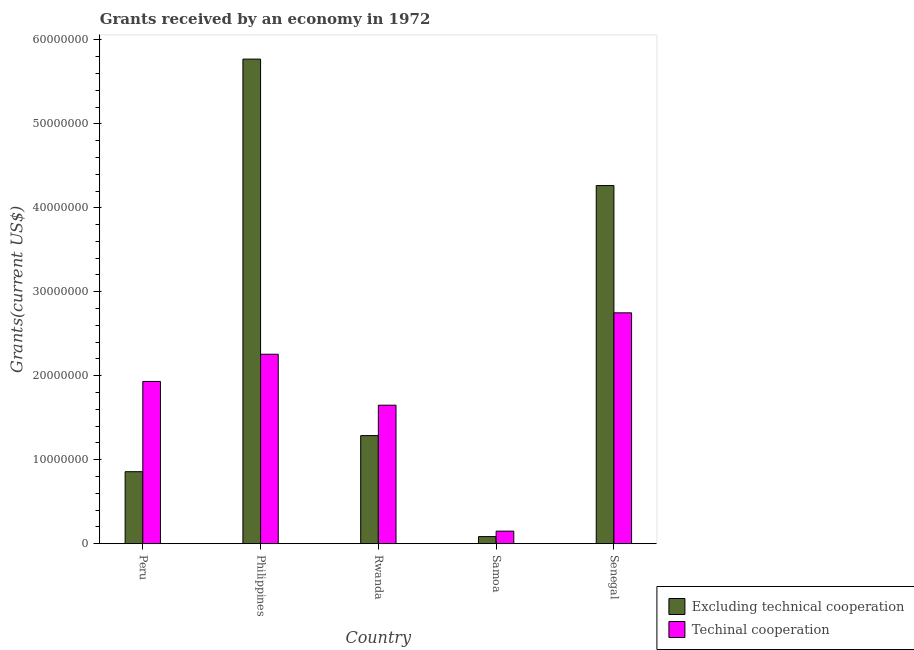How many different coloured bars are there?
Your answer should be compact. 2. How many groups of bars are there?
Give a very brief answer. 5. Are the number of bars per tick equal to the number of legend labels?
Make the answer very short. Yes. Are the number of bars on each tick of the X-axis equal?
Keep it short and to the point. Yes. What is the label of the 4th group of bars from the left?
Your answer should be compact. Samoa. In how many cases, is the number of bars for a given country not equal to the number of legend labels?
Ensure brevity in your answer.  0. What is the amount of grants received(including technical cooperation) in Peru?
Make the answer very short. 1.93e+07. Across all countries, what is the maximum amount of grants received(including technical cooperation)?
Ensure brevity in your answer.  2.75e+07. Across all countries, what is the minimum amount of grants received(including technical cooperation)?
Your answer should be very brief. 1.49e+06. In which country was the amount of grants received(including technical cooperation) maximum?
Your answer should be compact. Senegal. In which country was the amount of grants received(including technical cooperation) minimum?
Make the answer very short. Samoa. What is the total amount of grants received(excluding technical cooperation) in the graph?
Your response must be concise. 1.23e+08. What is the difference between the amount of grants received(including technical cooperation) in Peru and that in Philippines?
Your answer should be compact. -3.24e+06. What is the difference between the amount of grants received(including technical cooperation) in Samoa and the amount of grants received(excluding technical cooperation) in Philippines?
Your response must be concise. -5.62e+07. What is the average amount of grants received(including technical cooperation) per country?
Make the answer very short. 1.75e+07. What is the difference between the amount of grants received(including technical cooperation) and amount of grants received(excluding technical cooperation) in Samoa?
Your answer should be compact. 6.50e+05. In how many countries, is the amount of grants received(including technical cooperation) greater than 4000000 US$?
Ensure brevity in your answer.  4. What is the ratio of the amount of grants received(excluding technical cooperation) in Peru to that in Philippines?
Provide a short and direct response. 0.15. What is the difference between the highest and the second highest amount of grants received(including technical cooperation)?
Your answer should be compact. 4.93e+06. What is the difference between the highest and the lowest amount of grants received(excluding technical cooperation)?
Provide a succinct answer. 5.69e+07. In how many countries, is the amount of grants received(including technical cooperation) greater than the average amount of grants received(including technical cooperation) taken over all countries?
Your answer should be very brief. 3. Is the sum of the amount of grants received(excluding technical cooperation) in Peru and Philippines greater than the maximum amount of grants received(including technical cooperation) across all countries?
Ensure brevity in your answer.  Yes. What does the 2nd bar from the left in Samoa represents?
Offer a terse response. Techinal cooperation. What does the 2nd bar from the right in Peru represents?
Keep it short and to the point. Excluding technical cooperation. How many bars are there?
Give a very brief answer. 10. How many countries are there in the graph?
Offer a very short reply. 5. Are the values on the major ticks of Y-axis written in scientific E-notation?
Make the answer very short. No. Does the graph contain grids?
Your answer should be very brief. No. What is the title of the graph?
Your response must be concise. Grants received by an economy in 1972. What is the label or title of the X-axis?
Give a very brief answer. Country. What is the label or title of the Y-axis?
Give a very brief answer. Grants(current US$). What is the Grants(current US$) in Excluding technical cooperation in Peru?
Make the answer very short. 8.57e+06. What is the Grants(current US$) of Techinal cooperation in Peru?
Offer a very short reply. 1.93e+07. What is the Grants(current US$) of Excluding technical cooperation in Philippines?
Provide a succinct answer. 5.77e+07. What is the Grants(current US$) in Techinal cooperation in Philippines?
Ensure brevity in your answer.  2.26e+07. What is the Grants(current US$) of Excluding technical cooperation in Rwanda?
Keep it short and to the point. 1.29e+07. What is the Grants(current US$) of Techinal cooperation in Rwanda?
Ensure brevity in your answer.  1.65e+07. What is the Grants(current US$) in Excluding technical cooperation in Samoa?
Your response must be concise. 8.40e+05. What is the Grants(current US$) of Techinal cooperation in Samoa?
Offer a very short reply. 1.49e+06. What is the Grants(current US$) in Excluding technical cooperation in Senegal?
Keep it short and to the point. 4.26e+07. What is the Grants(current US$) in Techinal cooperation in Senegal?
Make the answer very short. 2.75e+07. Across all countries, what is the maximum Grants(current US$) of Excluding technical cooperation?
Give a very brief answer. 5.77e+07. Across all countries, what is the maximum Grants(current US$) in Techinal cooperation?
Provide a short and direct response. 2.75e+07. Across all countries, what is the minimum Grants(current US$) of Excluding technical cooperation?
Ensure brevity in your answer.  8.40e+05. Across all countries, what is the minimum Grants(current US$) in Techinal cooperation?
Provide a short and direct response. 1.49e+06. What is the total Grants(current US$) of Excluding technical cooperation in the graph?
Your response must be concise. 1.23e+08. What is the total Grants(current US$) of Techinal cooperation in the graph?
Offer a terse response. 8.74e+07. What is the difference between the Grants(current US$) in Excluding technical cooperation in Peru and that in Philippines?
Give a very brief answer. -4.91e+07. What is the difference between the Grants(current US$) of Techinal cooperation in Peru and that in Philippines?
Make the answer very short. -3.24e+06. What is the difference between the Grants(current US$) of Excluding technical cooperation in Peru and that in Rwanda?
Make the answer very short. -4.30e+06. What is the difference between the Grants(current US$) in Techinal cooperation in Peru and that in Rwanda?
Offer a very short reply. 2.83e+06. What is the difference between the Grants(current US$) of Excluding technical cooperation in Peru and that in Samoa?
Make the answer very short. 7.73e+06. What is the difference between the Grants(current US$) of Techinal cooperation in Peru and that in Samoa?
Offer a very short reply. 1.78e+07. What is the difference between the Grants(current US$) of Excluding technical cooperation in Peru and that in Senegal?
Give a very brief answer. -3.41e+07. What is the difference between the Grants(current US$) in Techinal cooperation in Peru and that in Senegal?
Provide a short and direct response. -8.17e+06. What is the difference between the Grants(current US$) in Excluding technical cooperation in Philippines and that in Rwanda?
Provide a short and direct response. 4.48e+07. What is the difference between the Grants(current US$) of Techinal cooperation in Philippines and that in Rwanda?
Make the answer very short. 6.07e+06. What is the difference between the Grants(current US$) of Excluding technical cooperation in Philippines and that in Samoa?
Your answer should be compact. 5.69e+07. What is the difference between the Grants(current US$) of Techinal cooperation in Philippines and that in Samoa?
Keep it short and to the point. 2.11e+07. What is the difference between the Grants(current US$) of Excluding technical cooperation in Philippines and that in Senegal?
Offer a terse response. 1.51e+07. What is the difference between the Grants(current US$) in Techinal cooperation in Philippines and that in Senegal?
Provide a short and direct response. -4.93e+06. What is the difference between the Grants(current US$) of Excluding technical cooperation in Rwanda and that in Samoa?
Ensure brevity in your answer.  1.20e+07. What is the difference between the Grants(current US$) of Techinal cooperation in Rwanda and that in Samoa?
Keep it short and to the point. 1.50e+07. What is the difference between the Grants(current US$) of Excluding technical cooperation in Rwanda and that in Senegal?
Your response must be concise. -2.98e+07. What is the difference between the Grants(current US$) of Techinal cooperation in Rwanda and that in Senegal?
Provide a succinct answer. -1.10e+07. What is the difference between the Grants(current US$) in Excluding technical cooperation in Samoa and that in Senegal?
Provide a short and direct response. -4.18e+07. What is the difference between the Grants(current US$) in Techinal cooperation in Samoa and that in Senegal?
Your answer should be very brief. -2.60e+07. What is the difference between the Grants(current US$) of Excluding technical cooperation in Peru and the Grants(current US$) of Techinal cooperation in Philippines?
Your response must be concise. -1.40e+07. What is the difference between the Grants(current US$) of Excluding technical cooperation in Peru and the Grants(current US$) of Techinal cooperation in Rwanda?
Give a very brief answer. -7.92e+06. What is the difference between the Grants(current US$) in Excluding technical cooperation in Peru and the Grants(current US$) in Techinal cooperation in Samoa?
Your answer should be compact. 7.08e+06. What is the difference between the Grants(current US$) in Excluding technical cooperation in Peru and the Grants(current US$) in Techinal cooperation in Senegal?
Offer a very short reply. -1.89e+07. What is the difference between the Grants(current US$) of Excluding technical cooperation in Philippines and the Grants(current US$) of Techinal cooperation in Rwanda?
Provide a succinct answer. 4.12e+07. What is the difference between the Grants(current US$) in Excluding technical cooperation in Philippines and the Grants(current US$) in Techinal cooperation in Samoa?
Your answer should be compact. 5.62e+07. What is the difference between the Grants(current US$) of Excluding technical cooperation in Philippines and the Grants(current US$) of Techinal cooperation in Senegal?
Your answer should be very brief. 3.02e+07. What is the difference between the Grants(current US$) of Excluding technical cooperation in Rwanda and the Grants(current US$) of Techinal cooperation in Samoa?
Offer a very short reply. 1.14e+07. What is the difference between the Grants(current US$) of Excluding technical cooperation in Rwanda and the Grants(current US$) of Techinal cooperation in Senegal?
Your response must be concise. -1.46e+07. What is the difference between the Grants(current US$) of Excluding technical cooperation in Samoa and the Grants(current US$) of Techinal cooperation in Senegal?
Your answer should be compact. -2.66e+07. What is the average Grants(current US$) in Excluding technical cooperation per country?
Your response must be concise. 2.45e+07. What is the average Grants(current US$) of Techinal cooperation per country?
Your answer should be very brief. 1.75e+07. What is the difference between the Grants(current US$) of Excluding technical cooperation and Grants(current US$) of Techinal cooperation in Peru?
Give a very brief answer. -1.08e+07. What is the difference between the Grants(current US$) of Excluding technical cooperation and Grants(current US$) of Techinal cooperation in Philippines?
Ensure brevity in your answer.  3.52e+07. What is the difference between the Grants(current US$) in Excluding technical cooperation and Grants(current US$) in Techinal cooperation in Rwanda?
Ensure brevity in your answer.  -3.62e+06. What is the difference between the Grants(current US$) in Excluding technical cooperation and Grants(current US$) in Techinal cooperation in Samoa?
Make the answer very short. -6.50e+05. What is the difference between the Grants(current US$) of Excluding technical cooperation and Grants(current US$) of Techinal cooperation in Senegal?
Your answer should be compact. 1.52e+07. What is the ratio of the Grants(current US$) in Excluding technical cooperation in Peru to that in Philippines?
Provide a short and direct response. 0.15. What is the ratio of the Grants(current US$) of Techinal cooperation in Peru to that in Philippines?
Make the answer very short. 0.86. What is the ratio of the Grants(current US$) in Excluding technical cooperation in Peru to that in Rwanda?
Your answer should be very brief. 0.67. What is the ratio of the Grants(current US$) in Techinal cooperation in Peru to that in Rwanda?
Provide a short and direct response. 1.17. What is the ratio of the Grants(current US$) of Excluding technical cooperation in Peru to that in Samoa?
Give a very brief answer. 10.2. What is the ratio of the Grants(current US$) in Techinal cooperation in Peru to that in Samoa?
Offer a terse response. 12.97. What is the ratio of the Grants(current US$) of Excluding technical cooperation in Peru to that in Senegal?
Ensure brevity in your answer.  0.2. What is the ratio of the Grants(current US$) in Techinal cooperation in Peru to that in Senegal?
Offer a very short reply. 0.7. What is the ratio of the Grants(current US$) in Excluding technical cooperation in Philippines to that in Rwanda?
Your answer should be very brief. 4.48. What is the ratio of the Grants(current US$) in Techinal cooperation in Philippines to that in Rwanda?
Make the answer very short. 1.37. What is the ratio of the Grants(current US$) of Excluding technical cooperation in Philippines to that in Samoa?
Provide a succinct answer. 68.7. What is the ratio of the Grants(current US$) of Techinal cooperation in Philippines to that in Samoa?
Your answer should be compact. 15.14. What is the ratio of the Grants(current US$) in Excluding technical cooperation in Philippines to that in Senegal?
Give a very brief answer. 1.35. What is the ratio of the Grants(current US$) of Techinal cooperation in Philippines to that in Senegal?
Ensure brevity in your answer.  0.82. What is the ratio of the Grants(current US$) in Excluding technical cooperation in Rwanda to that in Samoa?
Your response must be concise. 15.32. What is the ratio of the Grants(current US$) of Techinal cooperation in Rwanda to that in Samoa?
Your answer should be compact. 11.07. What is the ratio of the Grants(current US$) in Excluding technical cooperation in Rwanda to that in Senegal?
Ensure brevity in your answer.  0.3. What is the ratio of the Grants(current US$) in Techinal cooperation in Rwanda to that in Senegal?
Provide a short and direct response. 0.6. What is the ratio of the Grants(current US$) in Excluding technical cooperation in Samoa to that in Senegal?
Your answer should be compact. 0.02. What is the ratio of the Grants(current US$) in Techinal cooperation in Samoa to that in Senegal?
Offer a terse response. 0.05. What is the difference between the highest and the second highest Grants(current US$) in Excluding technical cooperation?
Provide a succinct answer. 1.51e+07. What is the difference between the highest and the second highest Grants(current US$) of Techinal cooperation?
Provide a short and direct response. 4.93e+06. What is the difference between the highest and the lowest Grants(current US$) of Excluding technical cooperation?
Your answer should be compact. 5.69e+07. What is the difference between the highest and the lowest Grants(current US$) in Techinal cooperation?
Provide a short and direct response. 2.60e+07. 